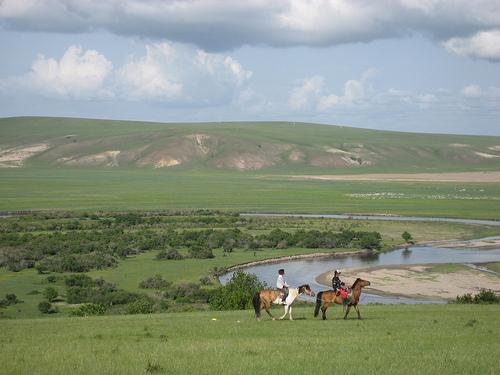What animals are in the scene?
Answer briefly. Horses. What are the animals doing?
Give a very brief answer. Walking. What are the people doing?
Short answer required. Riding horses. Do both of the animals have two toned bodies?
Keep it brief. No. What are the people sitting on?
Concise answer only. Horses. What is the body of water?
Give a very brief answer. River. Are people riding the horses?
Keep it brief. Yes. Are these animals tame?
Be succinct. Yes. 